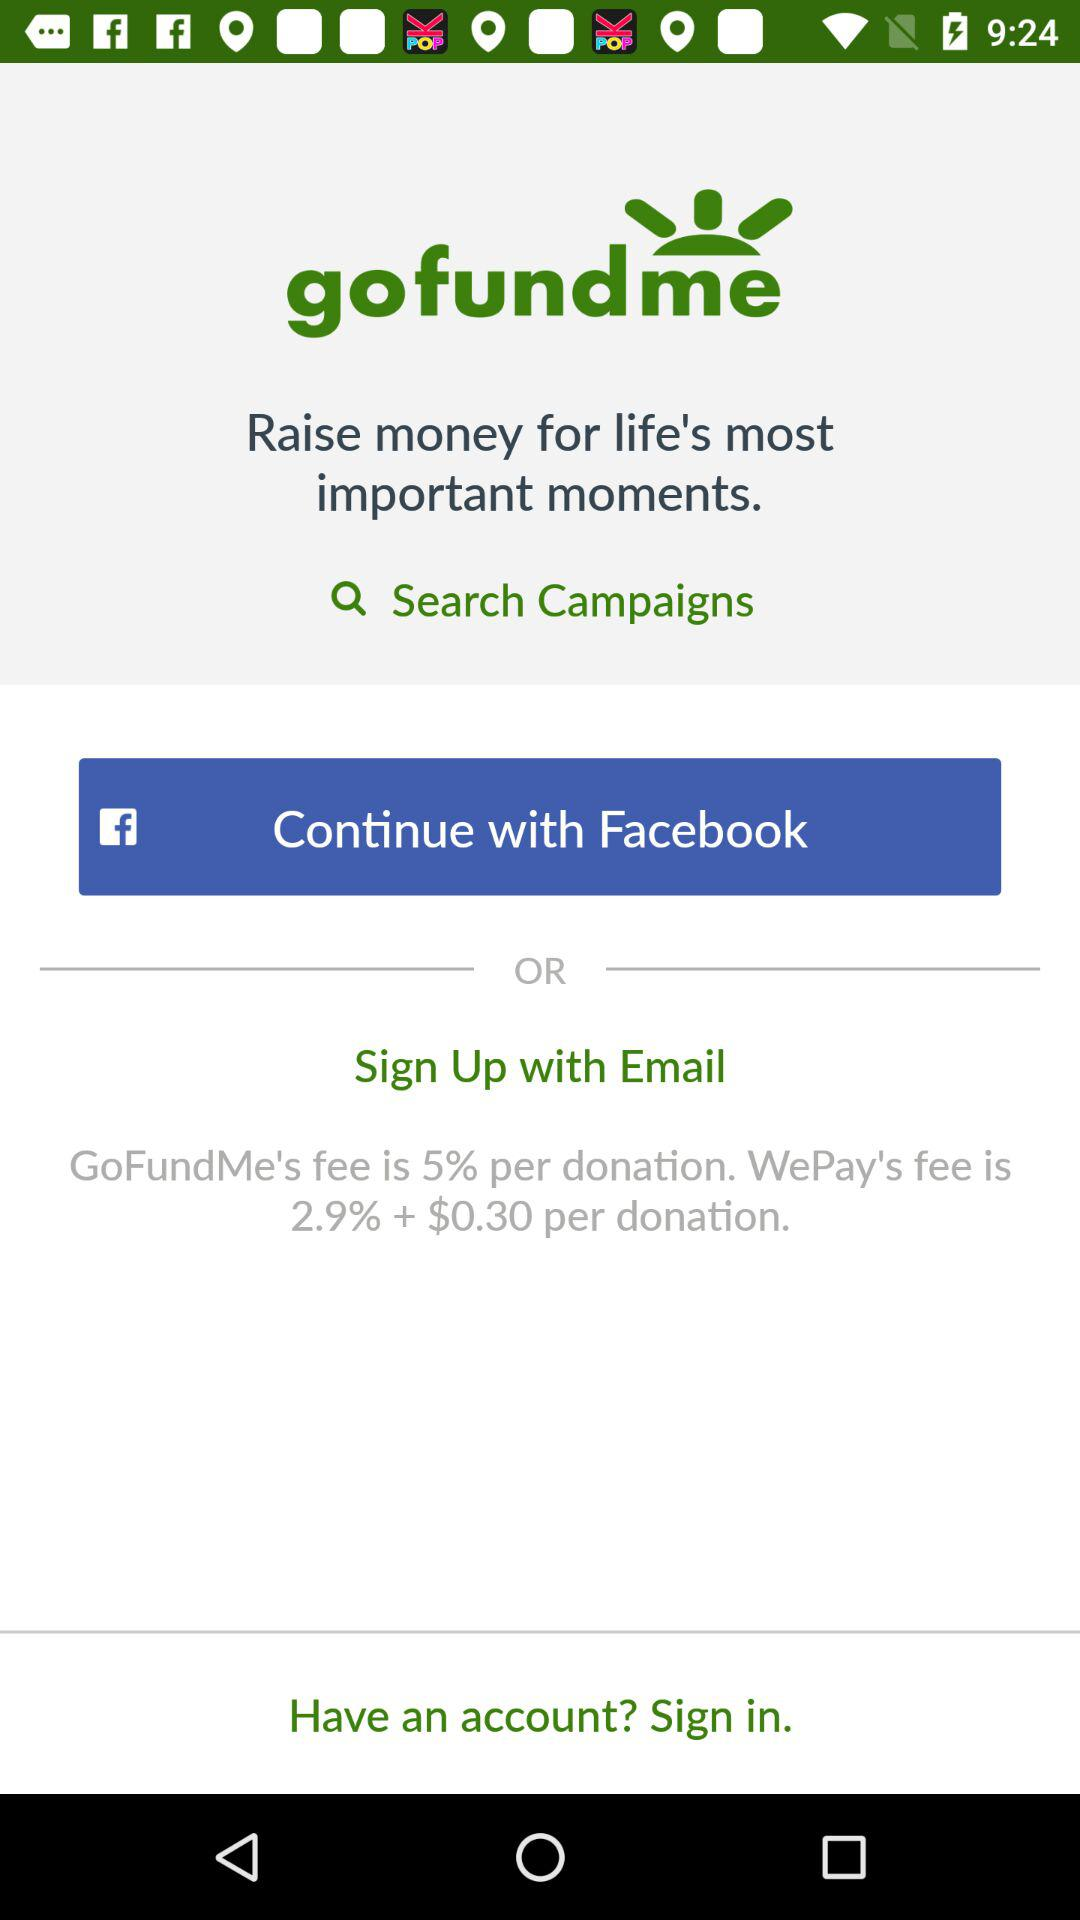How much is the fee of "WePay" per donation? The fee of "WePay" is 2.9% + $0.30 per donation. 